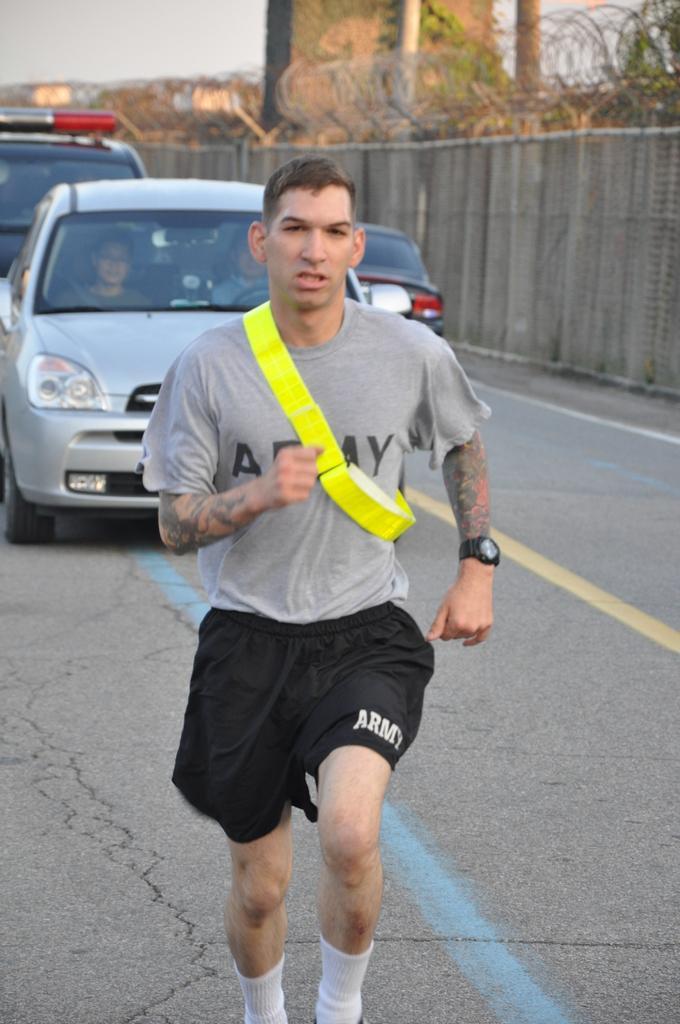In one or two sentences, can you explain what this image depicts? In this image we can see man running on the road, motor vehicles on the road, fences to the wall, creepers and sky. 